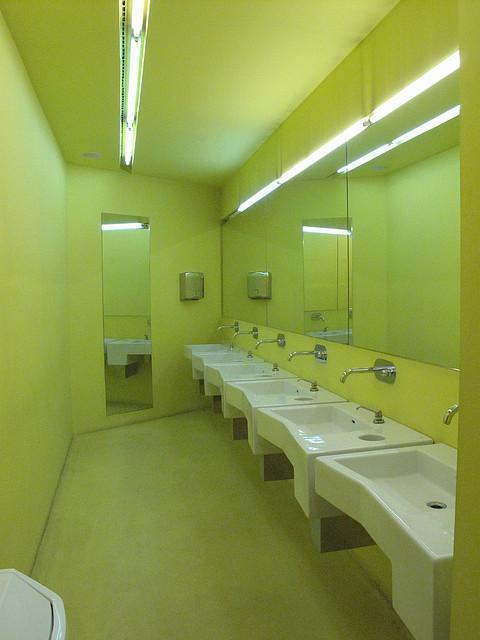How many sinks are in the bathroom?
Give a very brief answer. 6. How many sinks are in the photo?
Give a very brief answer. 3. 